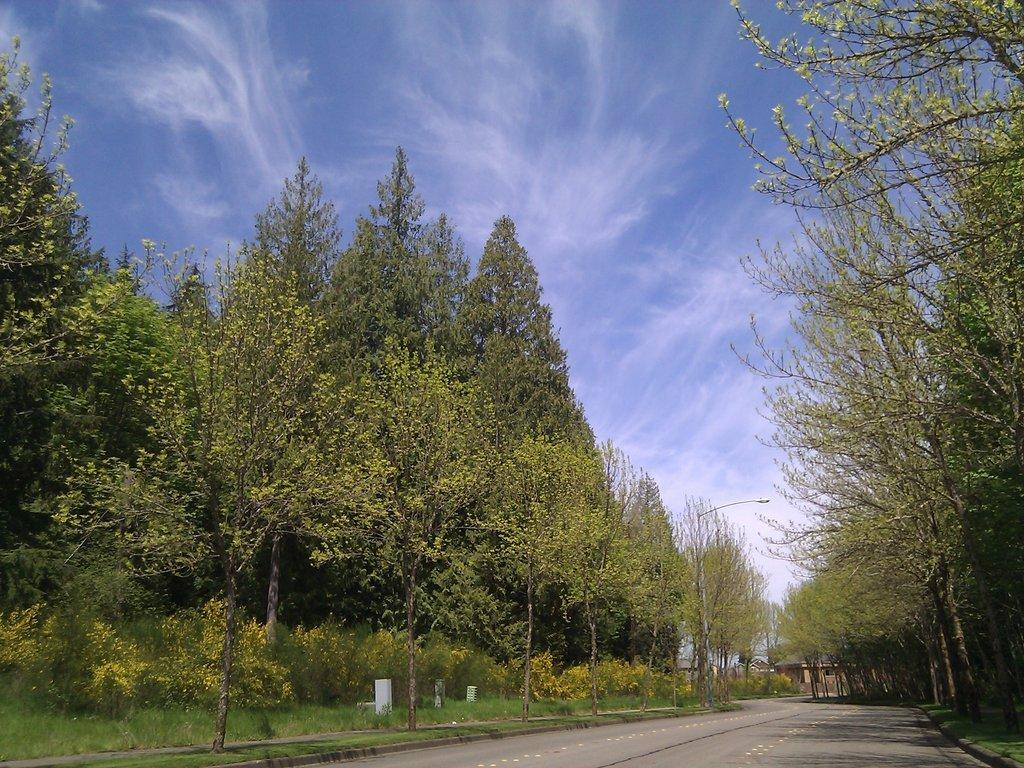What type of vegetation can be seen in the image? There are trees in the image. What is located at the bottom of the image? There is a road at the bottom of the image. What musical instrument is being played by the trees in the image? There is no musical instrument being played by the trees in the image, as trees are not capable of playing instruments. 